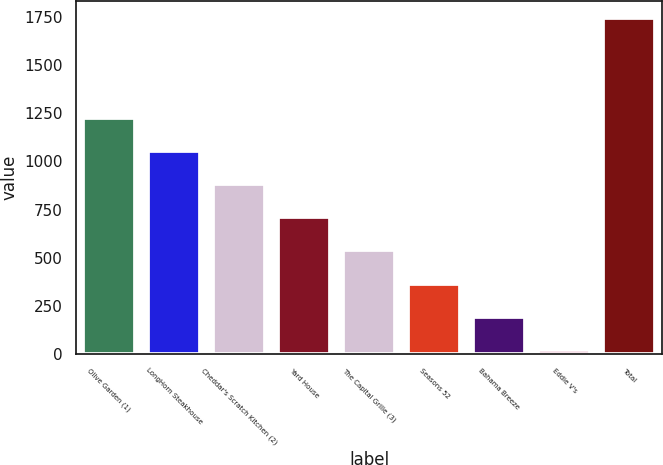Convert chart to OTSL. <chart><loc_0><loc_0><loc_500><loc_500><bar_chart><fcel>Olive Garden (1)<fcel>LongHorn Steakhouse<fcel>Cheddar's Scratch Kitchen (2)<fcel>Yard House<fcel>The Capital Grille (3)<fcel>Seasons 52<fcel>Bahama Breeze<fcel>Eddie V's<fcel>Total<nl><fcel>1227.9<fcel>1055.2<fcel>882.5<fcel>709.8<fcel>537.1<fcel>364.4<fcel>191.7<fcel>19<fcel>1746<nl></chart> 